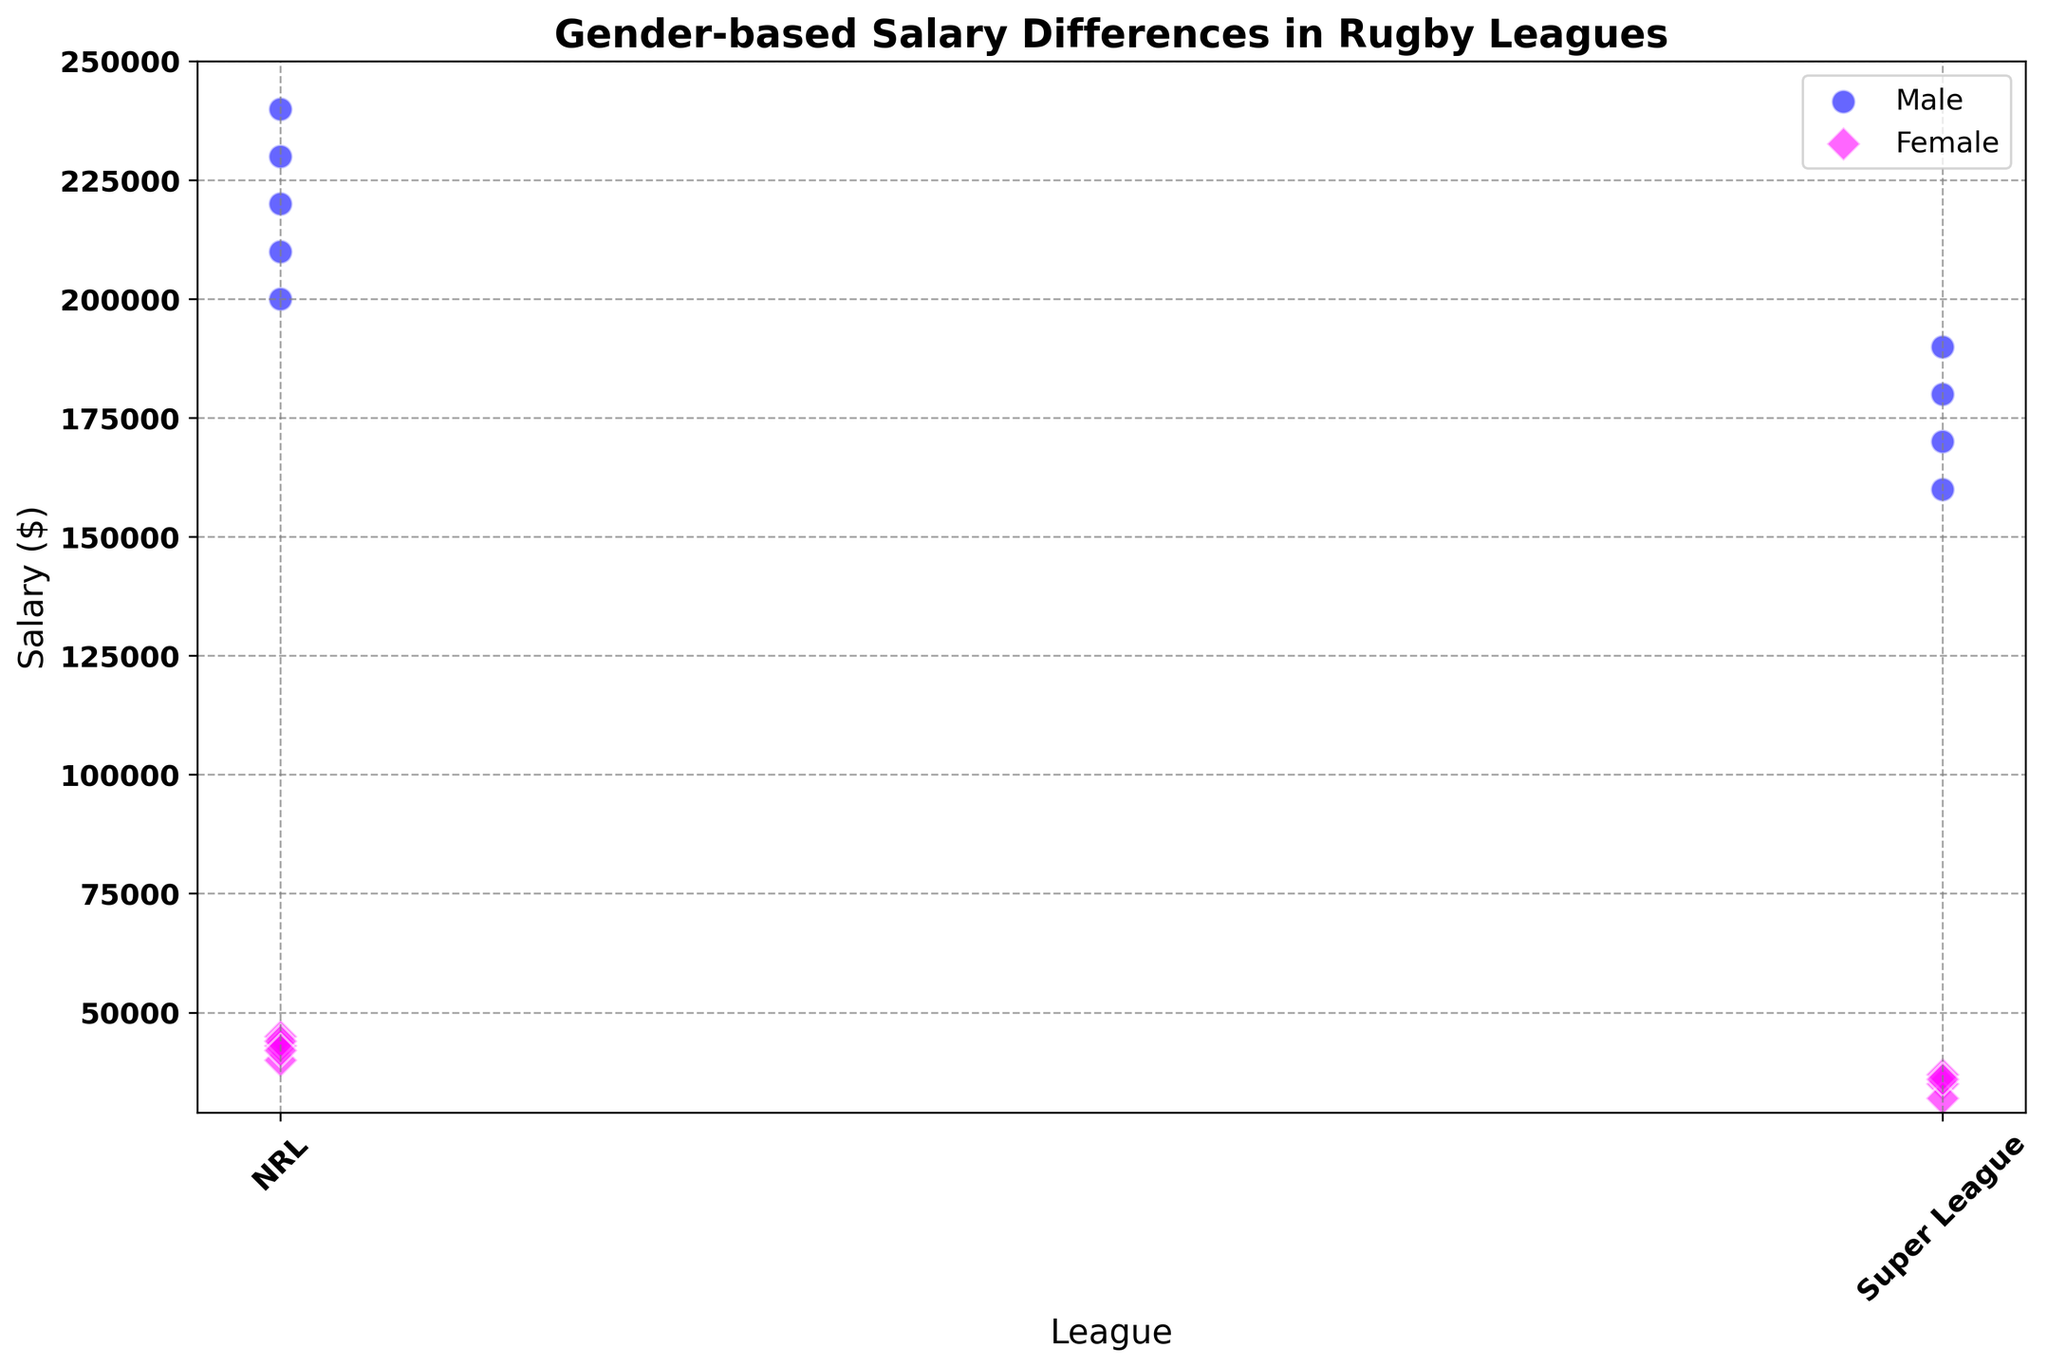What's the difference between the highest and lowest salaries for male players in the NRL? We need to find the highest and lowest salaries for male players in the NRL and then calculate the difference. The highest salary is $240,000 and the lowest salary is $200,000. The difference is $240,000 - $200,000 = $40,000.
Answer: $40,000 Which league shows the largest salary disparity between male and female players? To find the largest disparity, we compare the salary differences within each league. For the NRL, the average male salary is approximately $220,000 and the average female salary is approximately $42,000. The difference is $220,000 - $42,000 = $178,000. For the Super League, the average male salary is approximately $176,000 and the average female salary is approximately $35,500. The difference is $176,000 - $35,500 = $140,500. Therefore, the NRL shows the largest salary disparity.
Answer: NRL What is the average salary for female players in the Super League? To find this average, we sum the salaries of female players in the Super League: $35,000 + $32,000 + $37,000 + $36,000 = $140,000. There are 4 female players, so the average salary is $140,000 / 4 = $35,000.
Answer: $35,000 Are there any female players in the NRL earning more than $45,000? Reviewing the scatter plot for female players in the NRL, we see none of their salaries exceed $45,000.
Answer: No How does the salary range of male players in the Super League compare to that of male players in the NRL? The salary range for male players in the Super League is from $160,000 to $190,000. For male players in the NRL, the range is from $200,000 to $240,000. Hence, the NRL range is both higher in minimum and maximum salaries.
Answer: NRL Which gender has higher salary variation in the Super League? To determine this, we calculate the salary range for both genders. Male salaries range from $160,000 to $190,000, with a difference of $30,000. Female salaries range from $32,000 to $37,000, with a difference of $5,000. Therefore, male players exhibit higher salary variation.
Answer: Male What is the median salary for female players in the NRL? Median is the middle value in an ordered list. The salaries for female players in the NRL are $40,000, $42,000, $43,000, $44,000, and $45,000. The median salary, being the third value in this ordered list, is $43,000.
Answer: $43,000 